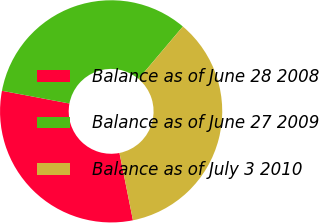Convert chart to OTSL. <chart><loc_0><loc_0><loc_500><loc_500><pie_chart><fcel>Balance as of June 28 2008<fcel>Balance as of June 27 2009<fcel>Balance as of July 3 2010<nl><fcel>31.11%<fcel>33.21%<fcel>35.68%<nl></chart> 